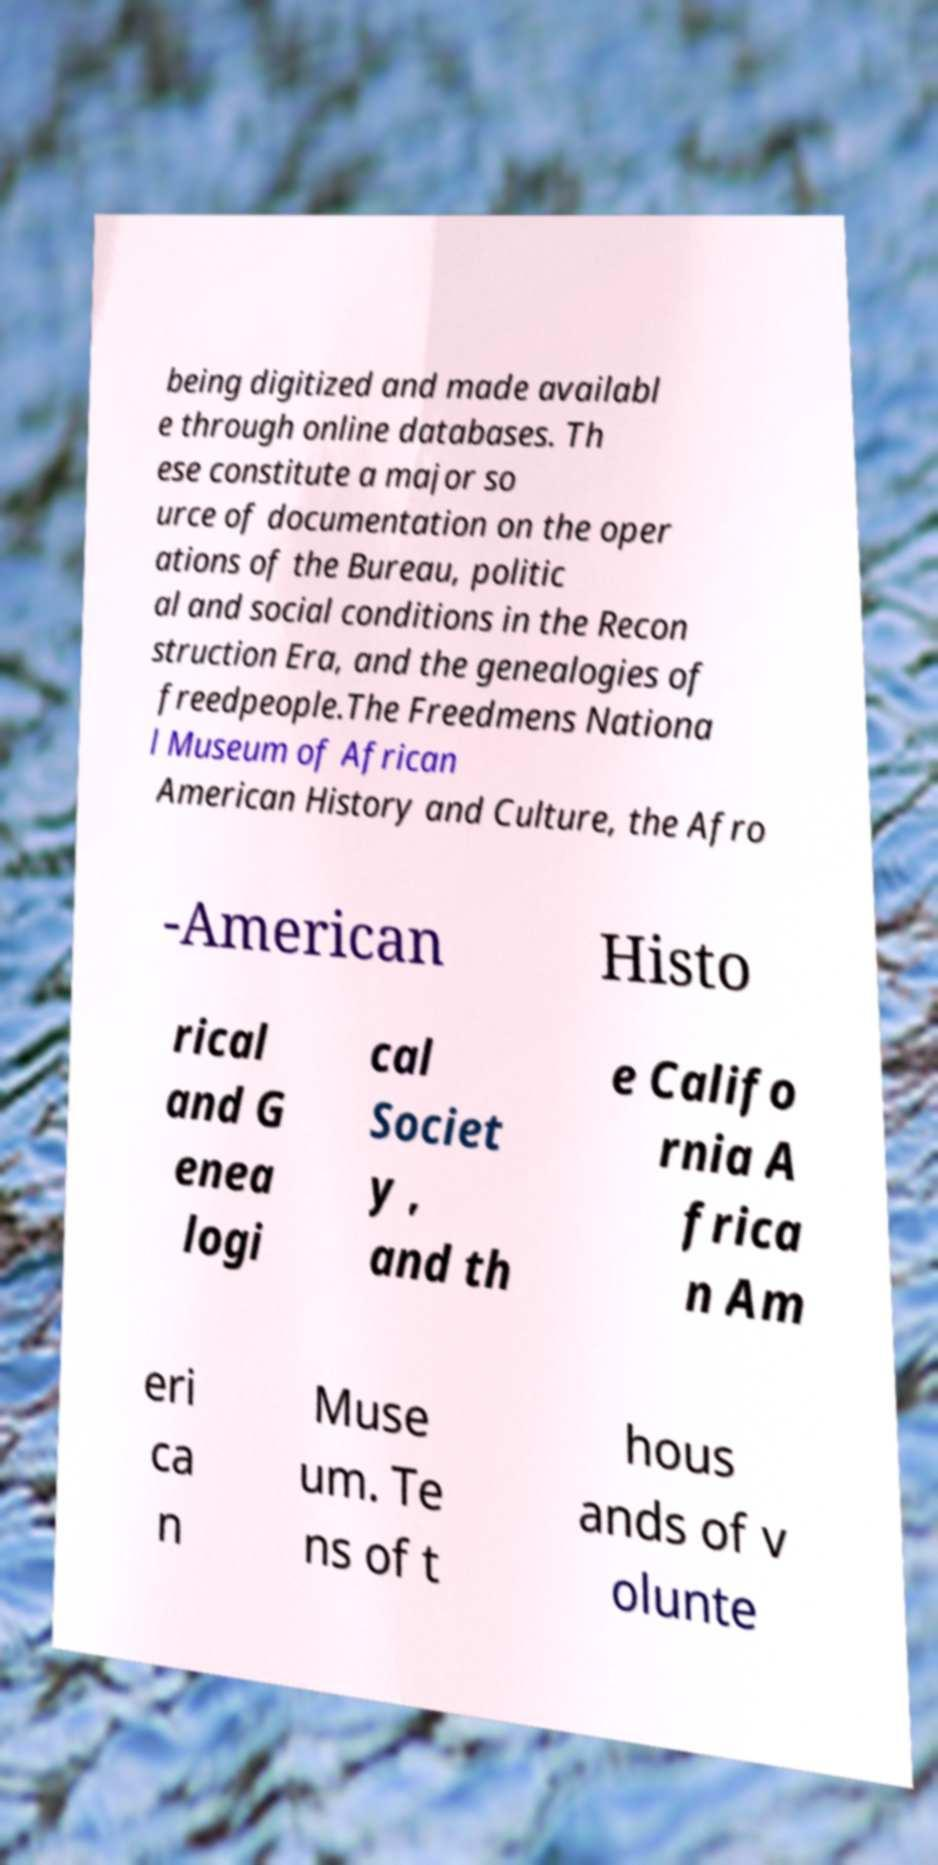Please read and relay the text visible in this image. What does it say? being digitized and made availabl e through online databases. Th ese constitute a major so urce of documentation on the oper ations of the Bureau, politic al and social conditions in the Recon struction Era, and the genealogies of freedpeople.The Freedmens Nationa l Museum of African American History and Culture, the Afro -American Histo rical and G enea logi cal Societ y , and th e Califo rnia A frica n Am eri ca n Muse um. Te ns of t hous ands of v olunte 